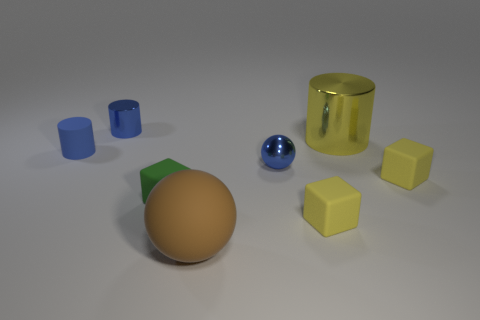Subtract all yellow blocks. How many were subtracted if there are1yellow blocks left? 1 Add 2 big metal cylinders. How many objects exist? 10 Subtract all spheres. How many objects are left? 6 Subtract 0 brown cubes. How many objects are left? 8 Subtract all small blue metal spheres. Subtract all matte cylinders. How many objects are left? 6 Add 1 small blue metal spheres. How many small blue metal spheres are left? 2 Add 5 large red metallic blocks. How many large red metallic blocks exist? 5 